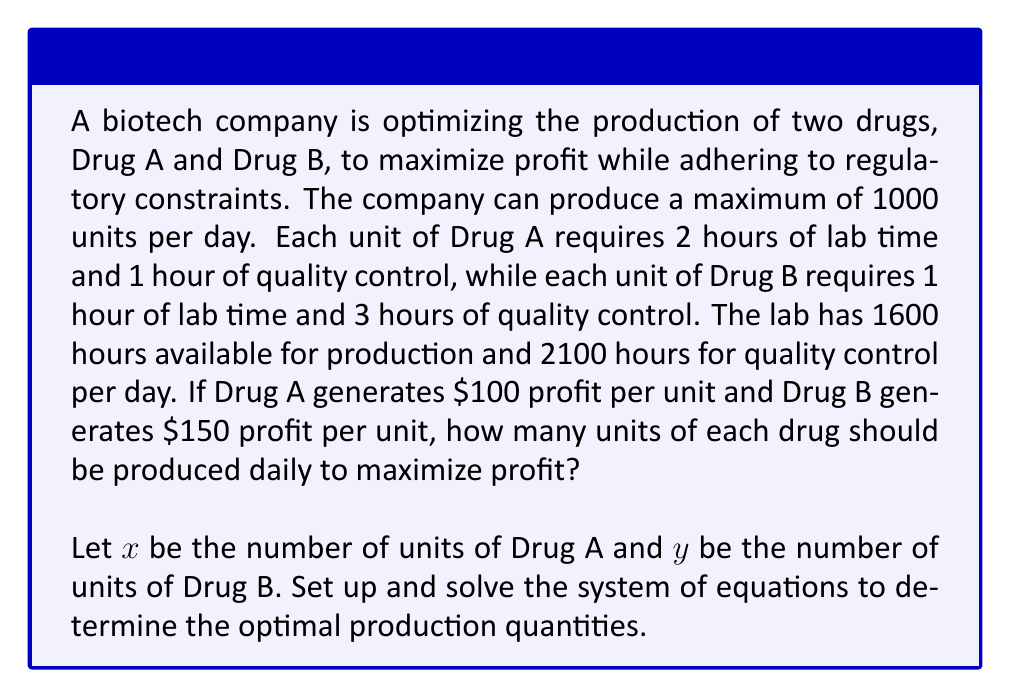Can you solve this math problem? To solve this problem, we need to set up a system of linear equations and inequalities based on the given constraints, then maximize the profit function.

1. Set up the constraints:
   a. Total units: $x + y \leq 1000$
   b. Lab time: $2x + y \leq 1600$
   c. Quality control time: $x + 3y \leq 2100$
   d. Non-negativity: $x \geq 0, y \geq 0$

2. Set up the profit function:
   $P = 100x + 150y$

3. To find the optimal solution, we need to check the intersection points of the constraint lines and the corners of the feasible region.

4. Find the intersection points:
   a. $x + y = 1000$ and $2x + y = 1600$:
      Solving these equations:
      $y = 1000 - x$
      $2x + (1000 - x) = 1600$
      $x = 600, y = 400$

   b. $2x + y = 1600$ and $x + 3y = 2100$:
      $2x + y = 1600$ ... (1)
      $x + 3y = 2100$ ... (2)
      Multiplying (1) by 3 and (2) by -2:
      $6x + 3y = 4800$
      $-2x - 6y = -4200$
      $4x - 3y = 600$
      $x = 450 + 0.75y$
      Substituting into (1):
      $2(450 + 0.75y) + y = 1600$
      $900 + 1.5y + y = 1600$
      $2.5y = 700$
      $y = 280$
      $x = 450 + 0.75(280) = 660$

   c. $x + y = 1000$ and $x + 3y = 2100$:
      $x = 1000 - y$
      $1000 - y + 3y = 2100$
      $2y = 1100$
      $y = 550$
      $x = 450$

5. Evaluate the profit function at each point:
   $(600, 400): P = 100(600) + 150(400) = 60000 + 60000 = 120000$
   $(660, 280): P = 100(660) + 150(280) = 66000 + 42000 = 108000$
   $(450, 550): P = 100(450) + 150(550) = 45000 + 82500 = 127500$

6. The maximum profit occurs at the point (450, 550), which represents 450 units of Drug A and 550 units of Drug B.
Answer: The company should produce 450 units of Drug A and 550 units of Drug B daily to maximize profit at $127,500. 